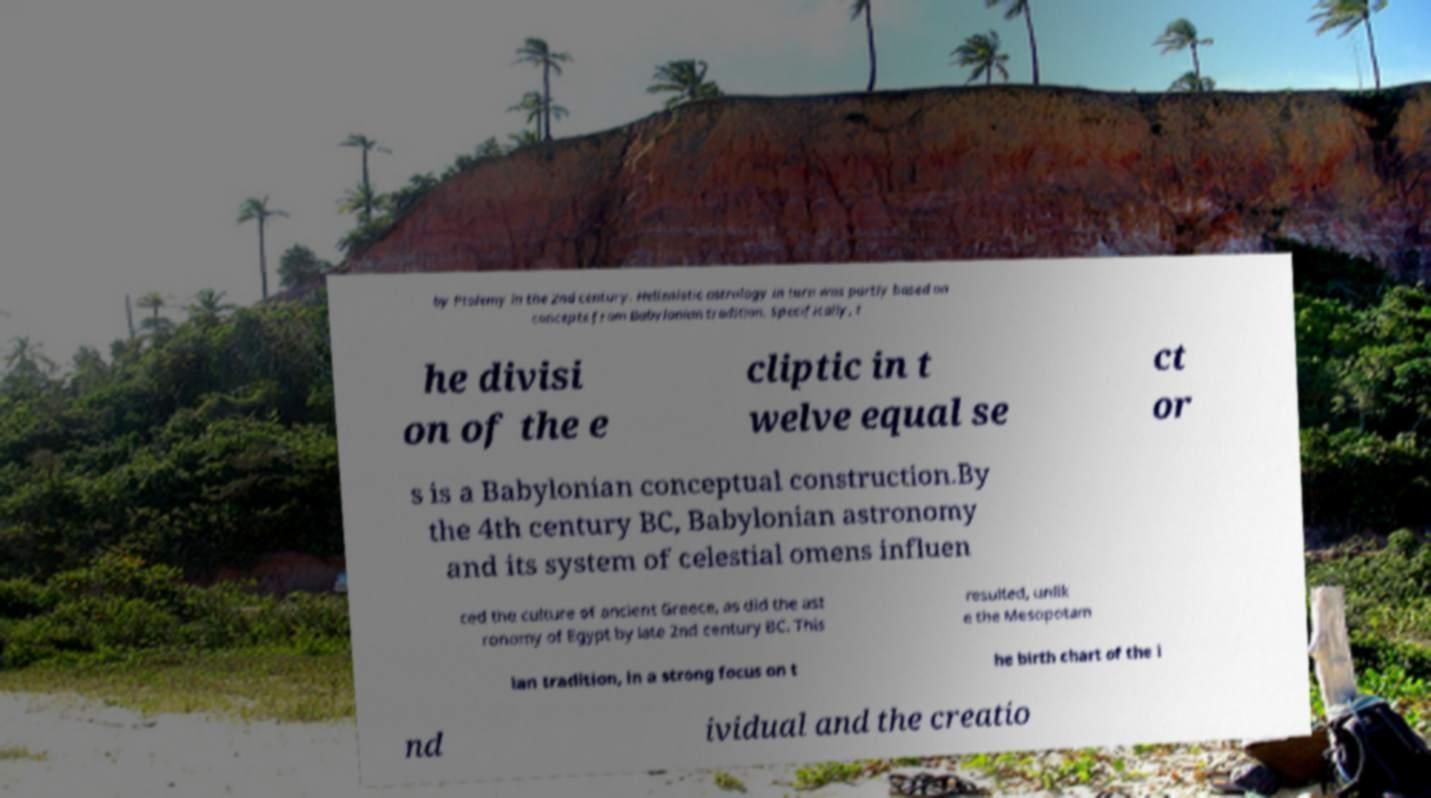Please identify and transcribe the text found in this image. by Ptolemy in the 2nd century. Hellenistic astrology in turn was partly based on concepts from Babylonian tradition. Specifically, t he divisi on of the e cliptic in t welve equal se ct or s is a Babylonian conceptual construction.By the 4th century BC, Babylonian astronomy and its system of celestial omens influen ced the culture of ancient Greece, as did the ast ronomy of Egypt by late 2nd century BC. This resulted, unlik e the Mesopotam ian tradition, in a strong focus on t he birth chart of the i nd ividual and the creatio 